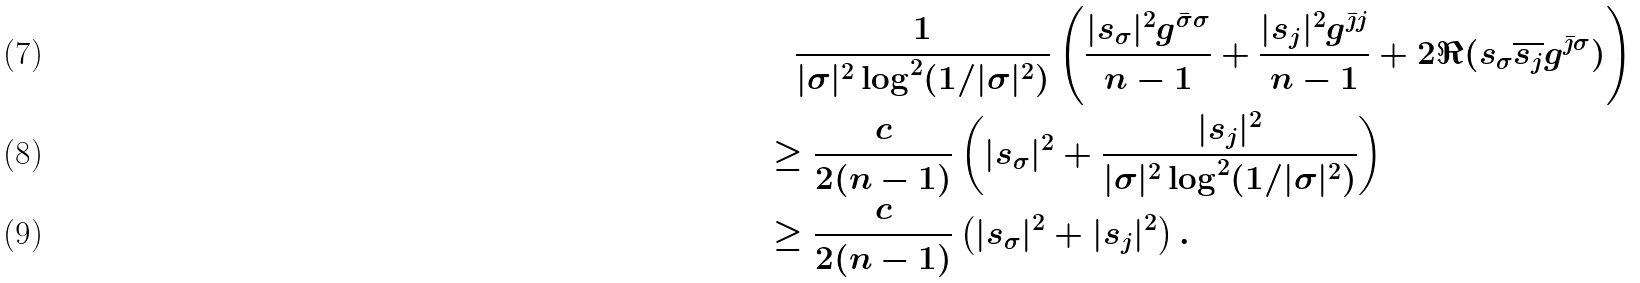Convert formula to latex. <formula><loc_0><loc_0><loc_500><loc_500>& \quad \frac { 1 } { | \sigma | ^ { 2 } \log ^ { 2 } ( 1 / | \sigma | ^ { 2 } ) } \left ( \frac { | s _ { \sigma } | ^ { 2 } g ^ { \bar { \sigma } \sigma } } { n - 1 } + \frac { | s _ { j } | ^ { 2 } g ^ { \bar { \jmath } j } } { n - 1 } + 2 \Re ( s _ { \sigma } \overline { s _ { j } } g ^ { \bar { \jmath } \sigma } ) \right ) \\ & \geq \frac { c } { 2 ( n - 1 ) } \left ( | s _ { \sigma } | ^ { 2 } + \frac { | s _ { j } | ^ { 2 } } { | \sigma | ^ { 2 } \log ^ { 2 } ( 1 / | \sigma | ^ { 2 } ) } \right ) \\ & \geq \frac { c } { 2 ( n - 1 ) } \left ( | s _ { \sigma } | ^ { 2 } + | s _ { j } | ^ { 2 } \right ) .</formula> 